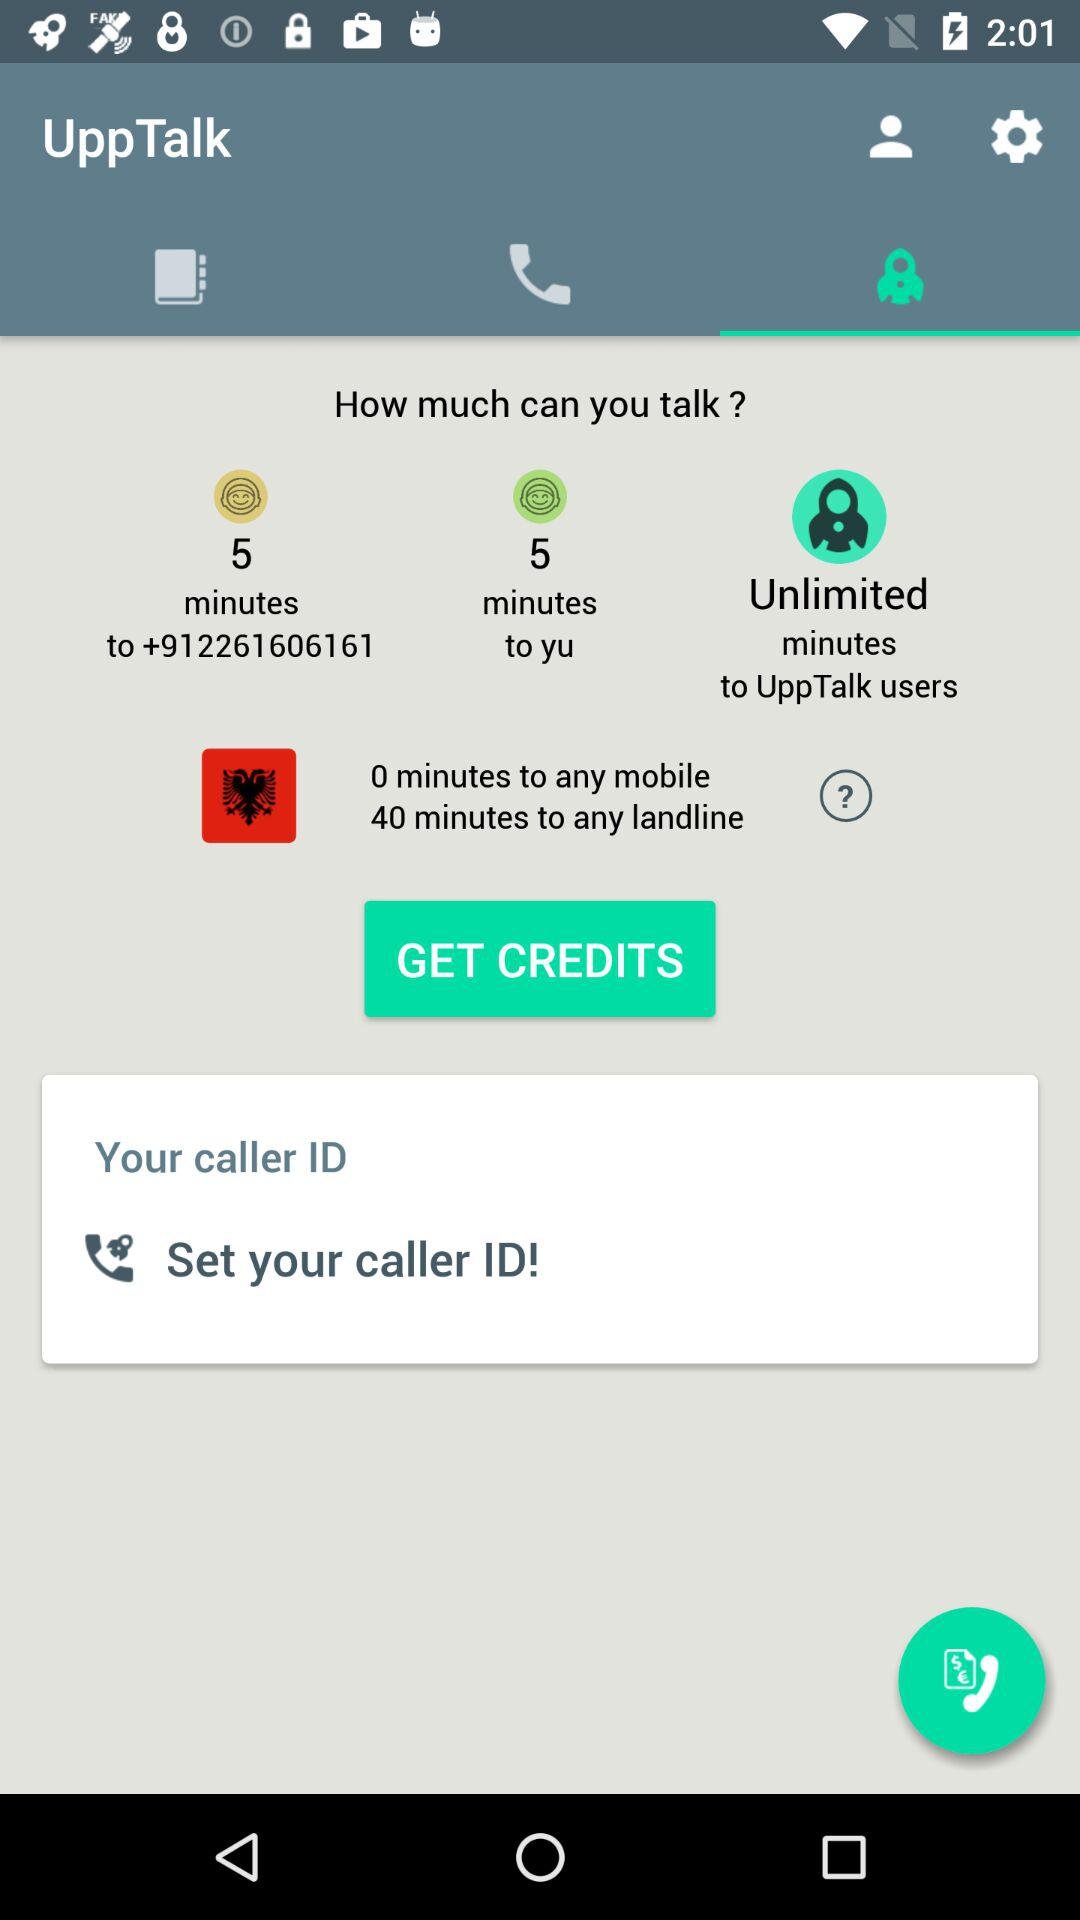For how many minutes can the user talk to any landline? The user can talk to any landline for 40 minutes. 